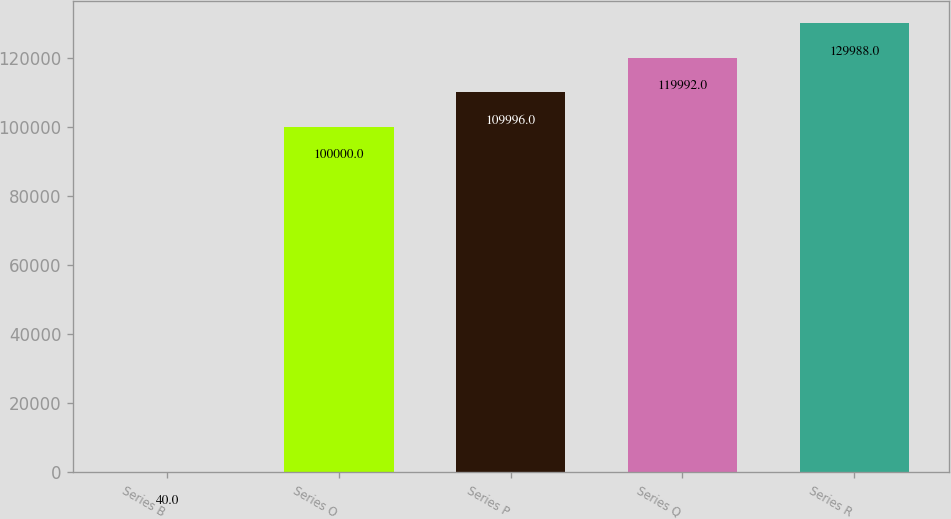<chart> <loc_0><loc_0><loc_500><loc_500><bar_chart><fcel>Series B<fcel>Series O<fcel>Series P<fcel>Series Q<fcel>Series R<nl><fcel>40<fcel>100000<fcel>109996<fcel>119992<fcel>129988<nl></chart> 